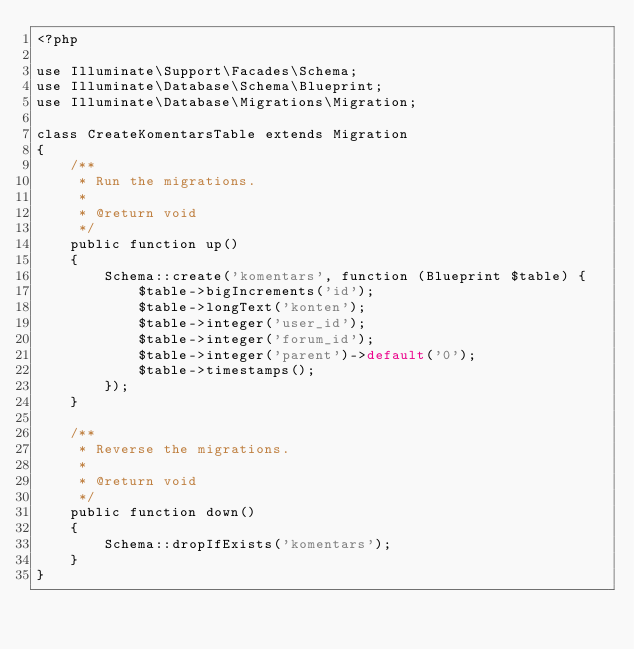<code> <loc_0><loc_0><loc_500><loc_500><_PHP_><?php

use Illuminate\Support\Facades\Schema;
use Illuminate\Database\Schema\Blueprint;
use Illuminate\Database\Migrations\Migration;

class CreateKomentarsTable extends Migration
{
    /**
     * Run the migrations.
     *
     * @return void
     */
    public function up()
    {
        Schema::create('komentars', function (Blueprint $table) {
            $table->bigIncrements('id');
            $table->longText('konten');
            $table->integer('user_id');
            $table->integer('forum_id');
            $table->integer('parent')->default('0');
            $table->timestamps();
        });
    }

    /**
     * Reverse the migrations.
     *
     * @return void
     */
    public function down()
    {
        Schema::dropIfExists('komentars');
    }
}
</code> 